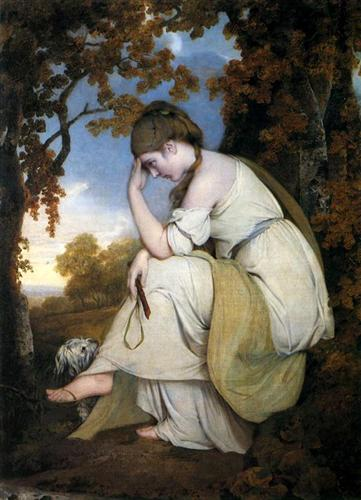Imagine a fantastical story involving this painting's scene. Once upon a time, in the heart of an enchanted forest, lived a maiden named Elara. She possessed the unique gift of communicating with nature. Her white dress, woven with the whispers of ancient trees, allowed her to blend seamlessly with the woodland surroundings. One evening, as the sun began to set, casting a soft golden glow on the forest, Elara felt a deep yearning to unite the realms of the human and the mystical. She sat down on her favorite rock, where the spirits of the forest gathered around her. With a heavy heart and a contemplative mind, she summoned the essence of the trees, and together they wove a spell. This spell created an ethereal bridge between worlds, allowing humans to see the hidden magic of nature. As Elara's gift spread throughout the kingdom, people began to coexist harmoniously with the mystical creatures that had long been forgotten. Peace and prosperity reigned, all thanks to the deep contemplation of one extraordinary maiden. 